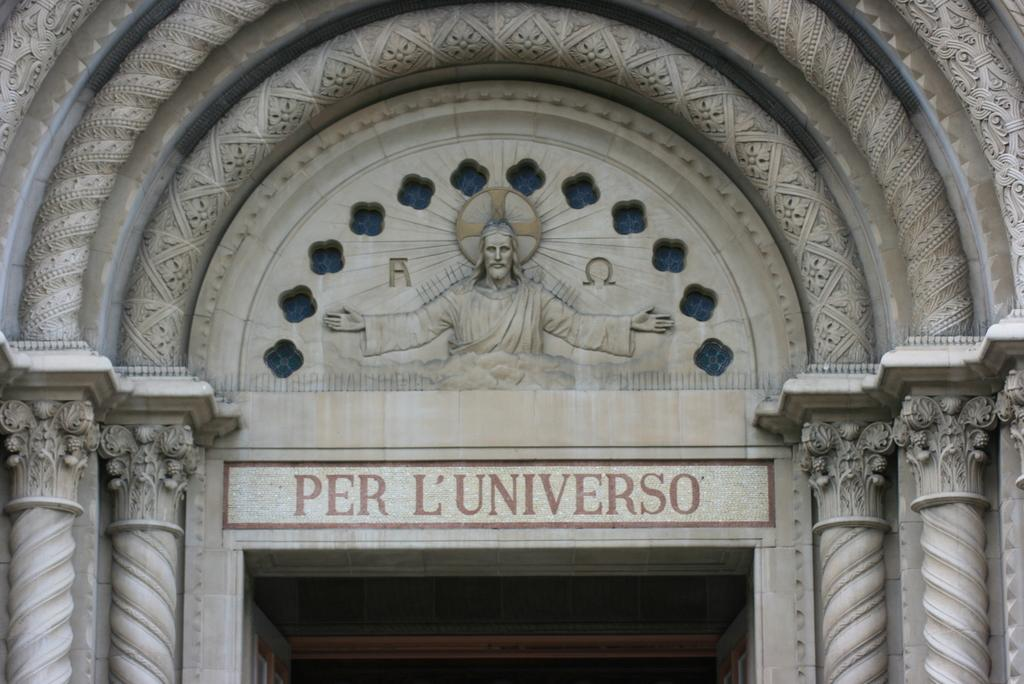What type of building is featured in the image? The image features the entrance of a church. What architectural elements can be seen at the entrance? The entrance has pillars. Is there any religious imagery present at the entrance? Yes, there is a picture of Jesus at the top of the entrance. What type of toothpaste is being used to clean the pillars in the image? There is no toothpaste present in the image, and the pillars are not being cleaned. 